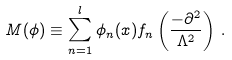Convert formula to latex. <formula><loc_0><loc_0><loc_500><loc_500>M ( \phi ) \equiv \sum _ { n = 1 } ^ { l } \phi _ { n } ( x ) f _ { n } \left ( \frac { - \partial ^ { 2 } } { \Lambda ^ { 2 } } \right ) \, .</formula> 